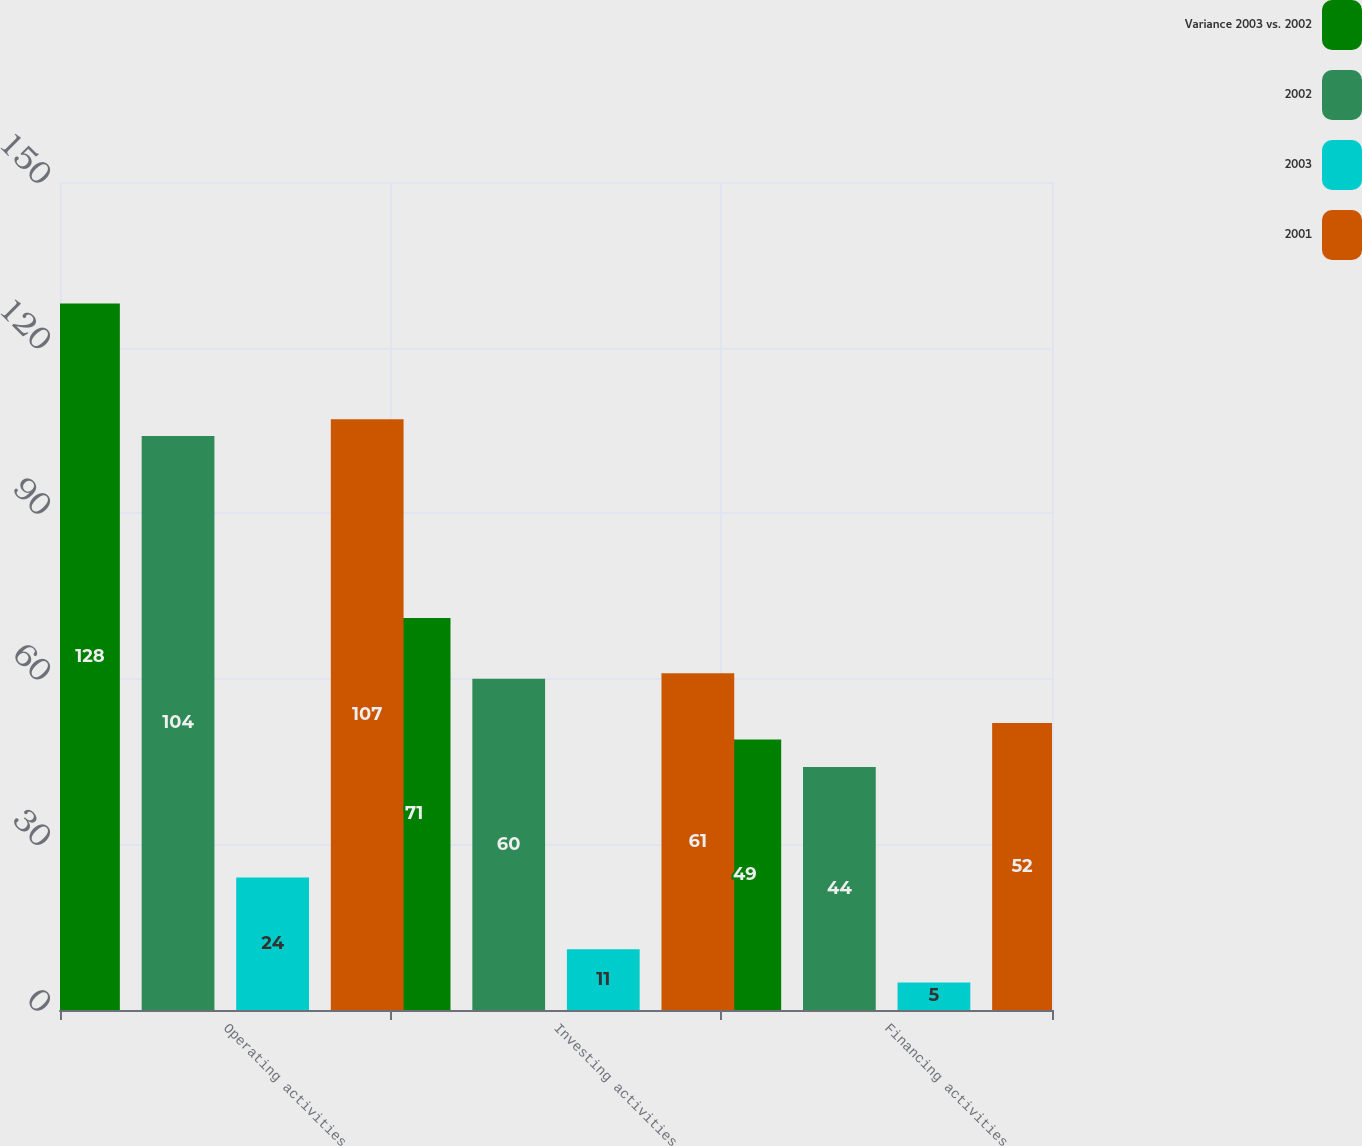<chart> <loc_0><loc_0><loc_500><loc_500><stacked_bar_chart><ecel><fcel>Operating activities<fcel>Investing activities<fcel>Financing activities<nl><fcel>Variance 2003 vs. 2002<fcel>128<fcel>71<fcel>49<nl><fcel>2002<fcel>104<fcel>60<fcel>44<nl><fcel>2003<fcel>24<fcel>11<fcel>5<nl><fcel>2001<fcel>107<fcel>61<fcel>52<nl></chart> 